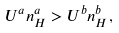Convert formula to latex. <formula><loc_0><loc_0><loc_500><loc_500>U ^ { a } n _ { H } ^ { a } > U ^ { b } n _ { H } ^ { b } ,</formula> 